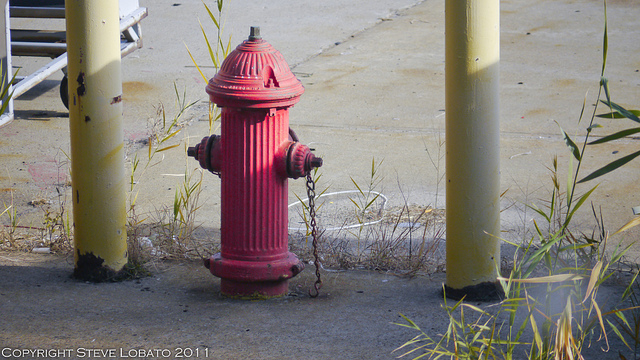Identify the text contained in this image. COPYRIGHT STEVE LOBATO 2011 